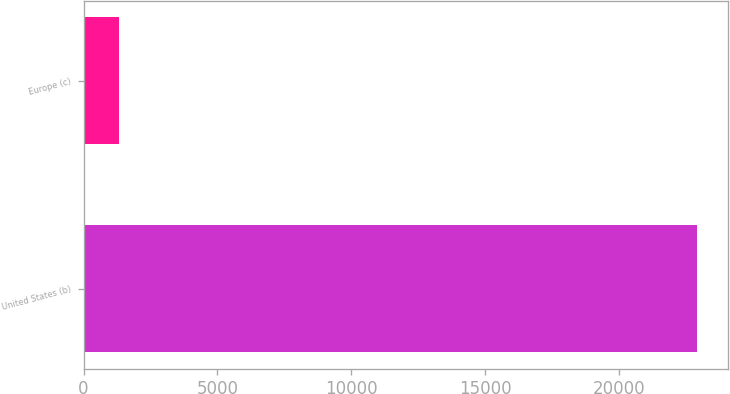Convert chart. <chart><loc_0><loc_0><loc_500><loc_500><bar_chart><fcel>United States (b)<fcel>Europe (c)<nl><fcel>22908<fcel>1317<nl></chart> 